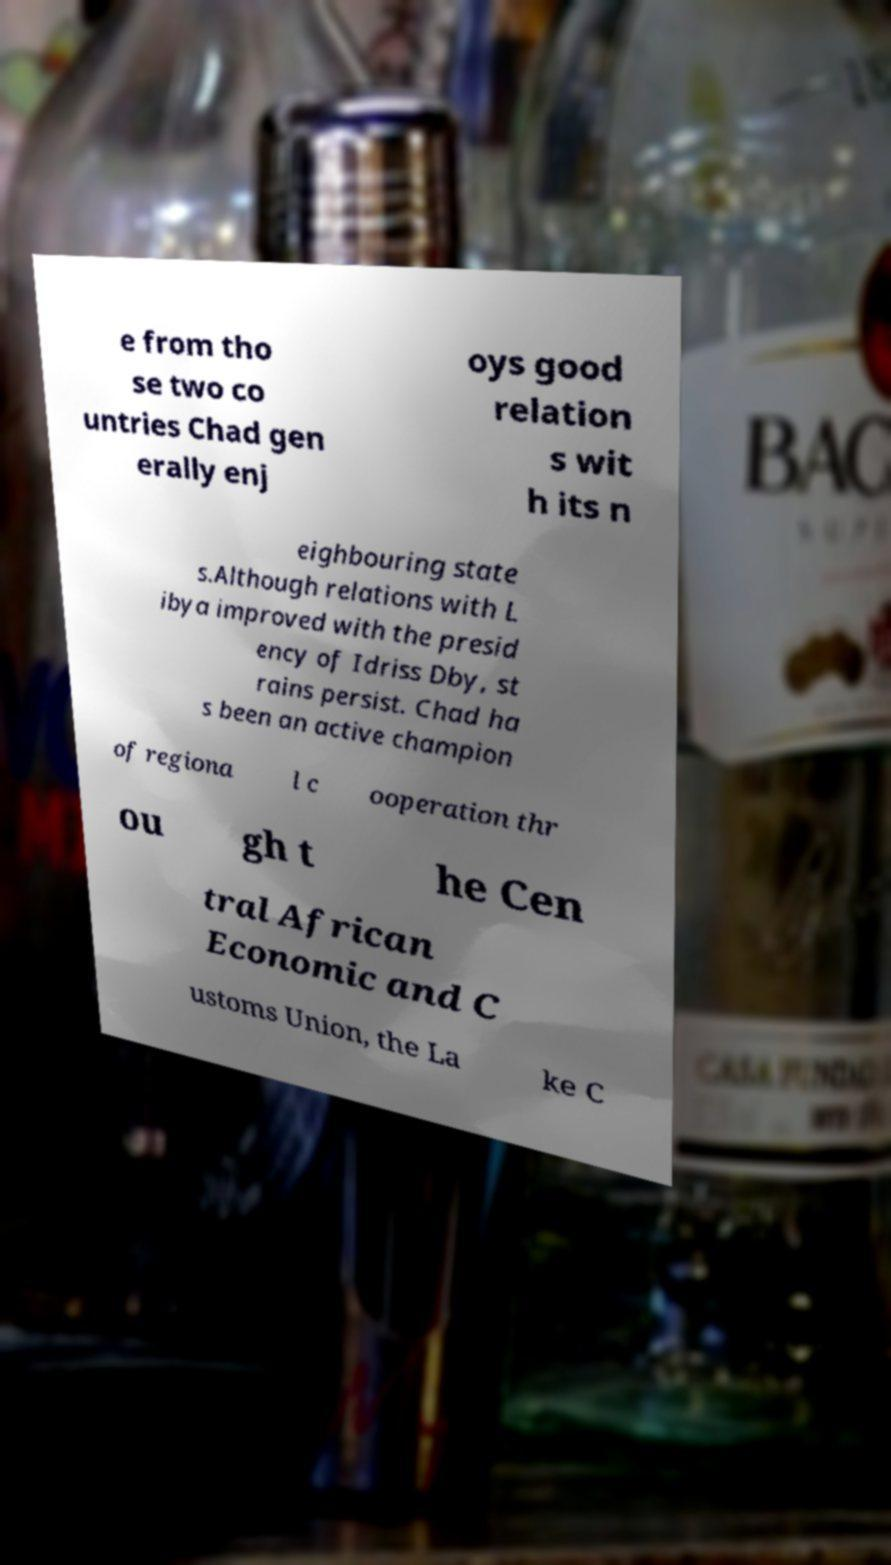Could you extract and type out the text from this image? e from tho se two co untries Chad gen erally enj oys good relation s wit h its n eighbouring state s.Although relations with L ibya improved with the presid ency of Idriss Dby, st rains persist. Chad ha s been an active champion of regiona l c ooperation thr ou gh t he Cen tral African Economic and C ustoms Union, the La ke C 